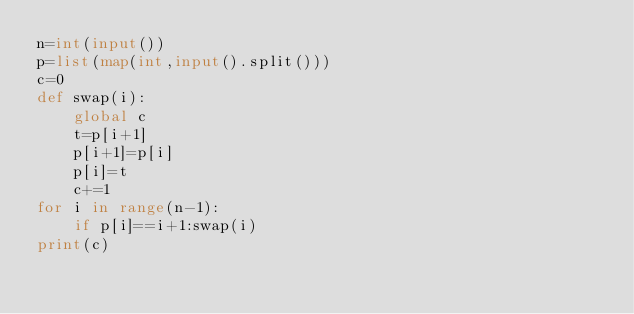<code> <loc_0><loc_0><loc_500><loc_500><_Python_>n=int(input())
p=list(map(int,input().split()))
c=0
def swap(i):
    global c
    t=p[i+1]
    p[i+1]=p[i]
    p[i]=t
    c+=1
for i in range(n-1):
    if p[i]==i+1:swap(i)
print(c)</code> 